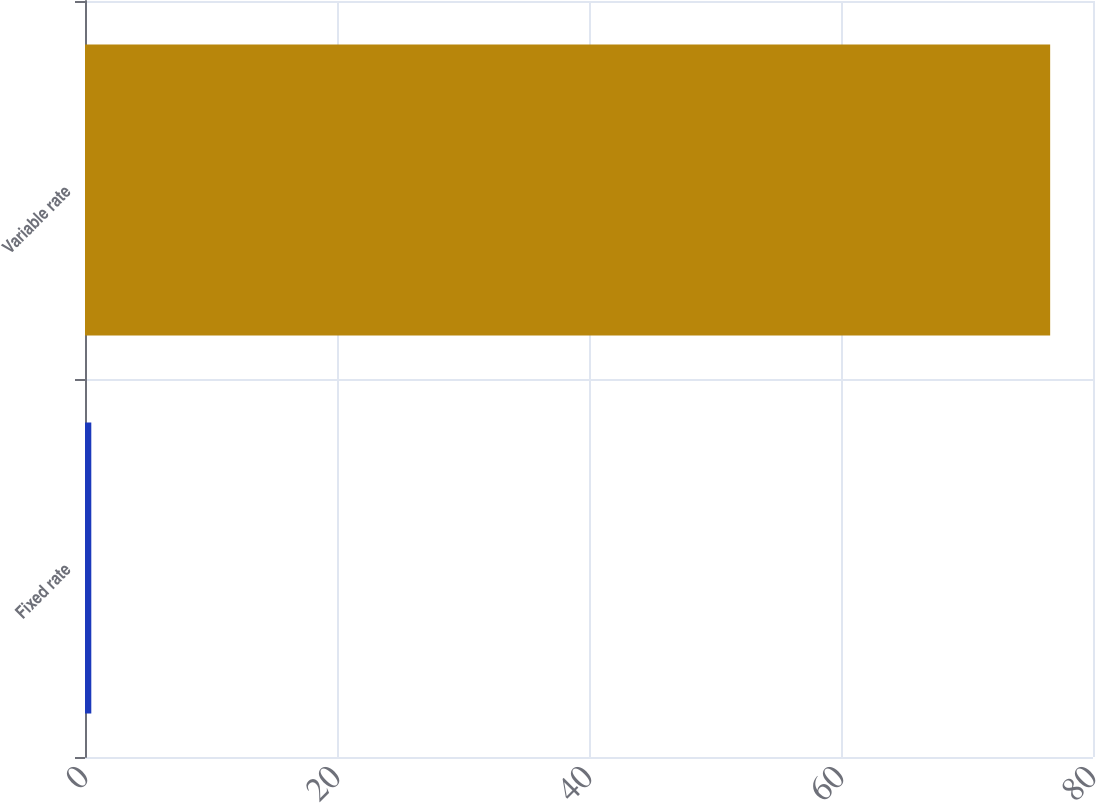Convert chart to OTSL. <chart><loc_0><loc_0><loc_500><loc_500><bar_chart><fcel>Fixed rate<fcel>Variable rate<nl><fcel>0.5<fcel>76.6<nl></chart> 